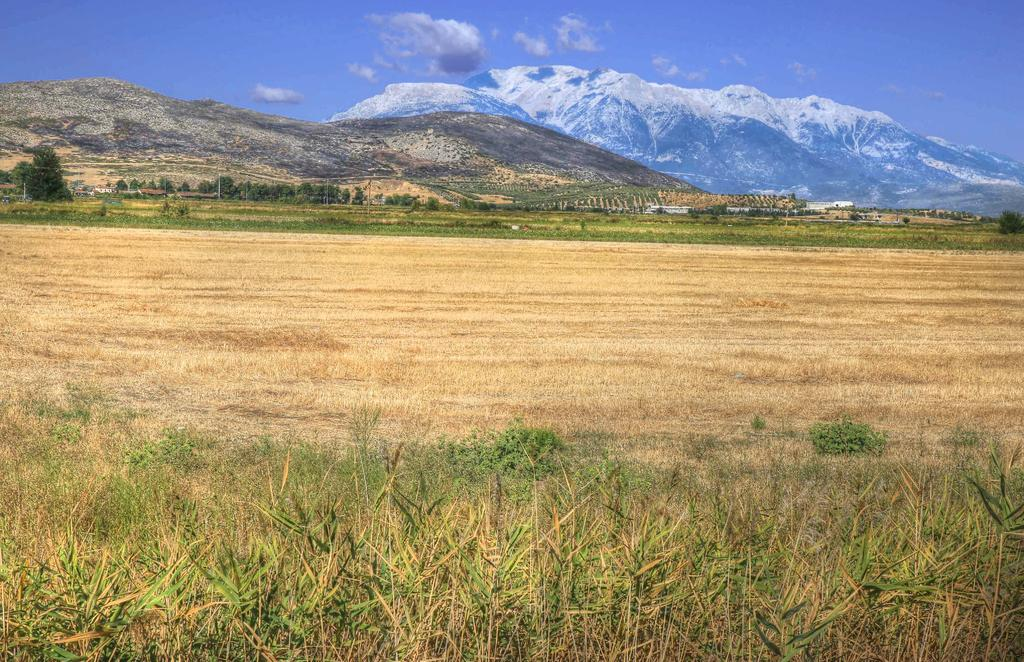What type of vegetation is present in the image? There is grass in the image. Are there any other natural elements visible in the image? Yes, there are trees in the image. What geographical feature can be seen in the distance? There is a mountain with snow in the image. What is visible at the top of the image? The sky is visible at the top of the image. Can you see a thumbprint on the mountain in the image? There is no thumbprint visible on the mountain in the image. Is there a bean-shaped lake in the image? There is no lake, bean-shaped or otherwise, present in the image. 